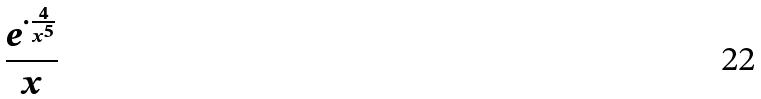<formula> <loc_0><loc_0><loc_500><loc_500>\frac { e ^ { \cdot \frac { 4 } { x ^ { 5 } } } } { x }</formula> 